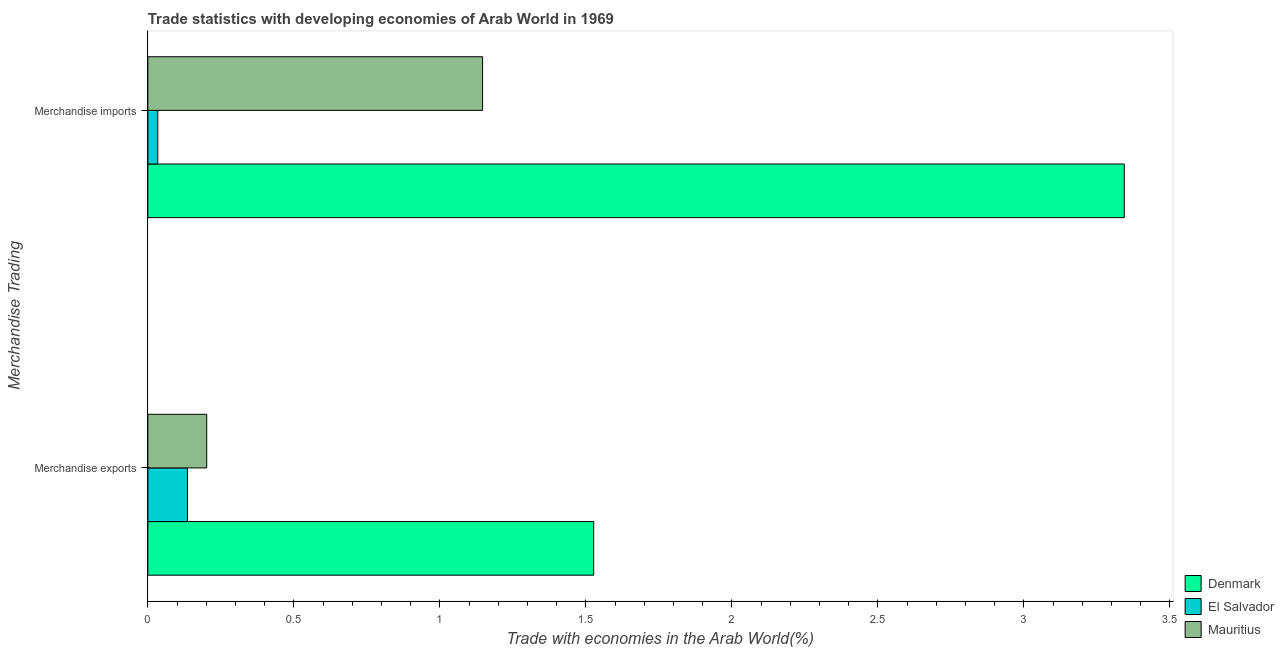How many different coloured bars are there?
Give a very brief answer. 3. How many groups of bars are there?
Your answer should be compact. 2. Are the number of bars per tick equal to the number of legend labels?
Offer a very short reply. Yes. What is the label of the 1st group of bars from the top?
Keep it short and to the point. Merchandise imports. What is the merchandise imports in El Salvador?
Give a very brief answer. 0.03. Across all countries, what is the maximum merchandise imports?
Ensure brevity in your answer.  3.34. Across all countries, what is the minimum merchandise imports?
Your response must be concise. 0.03. In which country was the merchandise exports maximum?
Your response must be concise. Denmark. In which country was the merchandise exports minimum?
Provide a short and direct response. El Salvador. What is the total merchandise imports in the graph?
Your answer should be compact. 4.52. What is the difference between the merchandise imports in Denmark and that in Mauritius?
Keep it short and to the point. 2.2. What is the difference between the merchandise exports in El Salvador and the merchandise imports in Mauritius?
Give a very brief answer. -1.01. What is the average merchandise exports per country?
Make the answer very short. 0.62. What is the difference between the merchandise imports and merchandise exports in Mauritius?
Your answer should be very brief. 0.94. In how many countries, is the merchandise exports greater than 2.3 %?
Provide a succinct answer. 0. What is the ratio of the merchandise exports in Denmark to that in Mauritius?
Provide a short and direct response. 7.58. In how many countries, is the merchandise exports greater than the average merchandise exports taken over all countries?
Keep it short and to the point. 1. What does the 1st bar from the top in Merchandise imports represents?
Provide a succinct answer. Mauritius. What does the 3rd bar from the bottom in Merchandise imports represents?
Offer a terse response. Mauritius. Are all the bars in the graph horizontal?
Your answer should be very brief. Yes. How many countries are there in the graph?
Give a very brief answer. 3. What is the difference between two consecutive major ticks on the X-axis?
Offer a very short reply. 0.5. Does the graph contain any zero values?
Your answer should be very brief. No. Does the graph contain grids?
Offer a terse response. No. Where does the legend appear in the graph?
Offer a very short reply. Bottom right. How many legend labels are there?
Ensure brevity in your answer.  3. What is the title of the graph?
Your answer should be compact. Trade statistics with developing economies of Arab World in 1969. What is the label or title of the X-axis?
Give a very brief answer. Trade with economies in the Arab World(%). What is the label or title of the Y-axis?
Offer a terse response. Merchandise Trading. What is the Trade with economies in the Arab World(%) of Denmark in Merchandise exports?
Provide a short and direct response. 1.53. What is the Trade with economies in the Arab World(%) in El Salvador in Merchandise exports?
Ensure brevity in your answer.  0.14. What is the Trade with economies in the Arab World(%) of Mauritius in Merchandise exports?
Offer a very short reply. 0.2. What is the Trade with economies in the Arab World(%) of Denmark in Merchandise imports?
Offer a terse response. 3.34. What is the Trade with economies in the Arab World(%) in El Salvador in Merchandise imports?
Ensure brevity in your answer.  0.03. What is the Trade with economies in the Arab World(%) in Mauritius in Merchandise imports?
Your answer should be compact. 1.15. Across all Merchandise Trading, what is the maximum Trade with economies in the Arab World(%) in Denmark?
Provide a succinct answer. 3.34. Across all Merchandise Trading, what is the maximum Trade with economies in the Arab World(%) in El Salvador?
Your answer should be very brief. 0.14. Across all Merchandise Trading, what is the maximum Trade with economies in the Arab World(%) of Mauritius?
Provide a short and direct response. 1.15. Across all Merchandise Trading, what is the minimum Trade with economies in the Arab World(%) of Denmark?
Give a very brief answer. 1.53. Across all Merchandise Trading, what is the minimum Trade with economies in the Arab World(%) of El Salvador?
Your answer should be very brief. 0.03. Across all Merchandise Trading, what is the minimum Trade with economies in the Arab World(%) in Mauritius?
Your response must be concise. 0.2. What is the total Trade with economies in the Arab World(%) of Denmark in the graph?
Offer a terse response. 4.87. What is the total Trade with economies in the Arab World(%) in El Salvador in the graph?
Provide a succinct answer. 0.17. What is the total Trade with economies in the Arab World(%) in Mauritius in the graph?
Your answer should be compact. 1.35. What is the difference between the Trade with economies in the Arab World(%) in Denmark in Merchandise exports and that in Merchandise imports?
Give a very brief answer. -1.82. What is the difference between the Trade with economies in the Arab World(%) of El Salvador in Merchandise exports and that in Merchandise imports?
Give a very brief answer. 0.1. What is the difference between the Trade with economies in the Arab World(%) of Mauritius in Merchandise exports and that in Merchandise imports?
Make the answer very short. -0.94. What is the difference between the Trade with economies in the Arab World(%) in Denmark in Merchandise exports and the Trade with economies in the Arab World(%) in El Salvador in Merchandise imports?
Keep it short and to the point. 1.49. What is the difference between the Trade with economies in the Arab World(%) of Denmark in Merchandise exports and the Trade with economies in the Arab World(%) of Mauritius in Merchandise imports?
Provide a short and direct response. 0.38. What is the difference between the Trade with economies in the Arab World(%) in El Salvador in Merchandise exports and the Trade with economies in the Arab World(%) in Mauritius in Merchandise imports?
Give a very brief answer. -1.01. What is the average Trade with economies in the Arab World(%) of Denmark per Merchandise Trading?
Ensure brevity in your answer.  2.44. What is the average Trade with economies in the Arab World(%) of El Salvador per Merchandise Trading?
Keep it short and to the point. 0.08. What is the average Trade with economies in the Arab World(%) of Mauritius per Merchandise Trading?
Your response must be concise. 0.67. What is the difference between the Trade with economies in the Arab World(%) in Denmark and Trade with economies in the Arab World(%) in El Salvador in Merchandise exports?
Make the answer very short. 1.39. What is the difference between the Trade with economies in the Arab World(%) of Denmark and Trade with economies in the Arab World(%) of Mauritius in Merchandise exports?
Provide a short and direct response. 1.33. What is the difference between the Trade with economies in the Arab World(%) of El Salvador and Trade with economies in the Arab World(%) of Mauritius in Merchandise exports?
Your response must be concise. -0.07. What is the difference between the Trade with economies in the Arab World(%) in Denmark and Trade with economies in the Arab World(%) in El Salvador in Merchandise imports?
Provide a succinct answer. 3.31. What is the difference between the Trade with economies in the Arab World(%) of Denmark and Trade with economies in the Arab World(%) of Mauritius in Merchandise imports?
Your response must be concise. 2.2. What is the difference between the Trade with economies in the Arab World(%) of El Salvador and Trade with economies in the Arab World(%) of Mauritius in Merchandise imports?
Make the answer very short. -1.11. What is the ratio of the Trade with economies in the Arab World(%) in Denmark in Merchandise exports to that in Merchandise imports?
Your response must be concise. 0.46. What is the ratio of the Trade with economies in the Arab World(%) of El Salvador in Merchandise exports to that in Merchandise imports?
Offer a terse response. 3.98. What is the ratio of the Trade with economies in the Arab World(%) in Mauritius in Merchandise exports to that in Merchandise imports?
Offer a terse response. 0.18. What is the difference between the highest and the second highest Trade with economies in the Arab World(%) in Denmark?
Provide a succinct answer. 1.82. What is the difference between the highest and the second highest Trade with economies in the Arab World(%) of El Salvador?
Offer a very short reply. 0.1. What is the difference between the highest and the second highest Trade with economies in the Arab World(%) of Mauritius?
Your answer should be very brief. 0.94. What is the difference between the highest and the lowest Trade with economies in the Arab World(%) in Denmark?
Give a very brief answer. 1.82. What is the difference between the highest and the lowest Trade with economies in the Arab World(%) of El Salvador?
Offer a terse response. 0.1. What is the difference between the highest and the lowest Trade with economies in the Arab World(%) in Mauritius?
Offer a terse response. 0.94. 